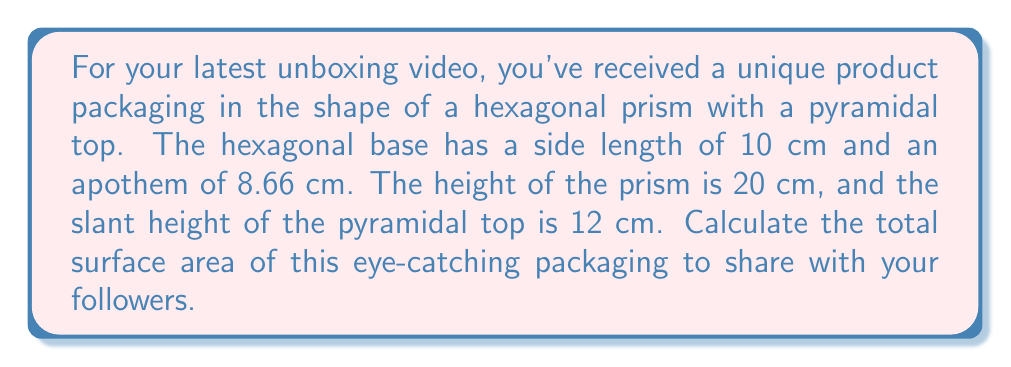Solve this math problem. Let's break this down step-by-step:

1) First, we need to calculate the area of the hexagonal base:
   Area of hexagon = $6 \times \frac{1}{2} \times$ side length $\times$ apothem
   $$ A_{hex} = 6 \times \frac{1}{2} \times 10 \times 8.66 = 259.8 \text{ cm}^2 $$

2) The lateral surface area of the prism is the perimeter of the base times the height:
   $$ A_{lateral} = 6 \times 10 \times 20 = 1200 \text{ cm}^2 $$

3) For the pyramidal top, we need to find the area of 6 triangular faces:
   First, let's find the base of each triangle (which is the side of the hexagon): 10 cm
   The height of each triangle is the slant height: 12 cm
   Area of one triangular face = $\frac{1}{2} \times$ base $\times$ height
   $$ A_{triangle} = \frac{1}{2} \times 10 \times 12 = 60 \text{ cm}^2 $$
   Total area of pyramidal top = $6 \times 60 = 360 \text{ cm}^2$

4) Now, we sum all the parts:
   Total Surface Area = Area of hexagonal base + Lateral surface area of prism + Area of pyramidal top
   $$ A_{total} = 259.8 + 1200 + 360 = 1819.8 \text{ cm}^2 $$
Answer: $1819.8 \text{ cm}^2$ 